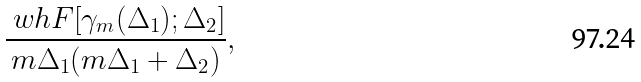Convert formula to latex. <formula><loc_0><loc_0><loc_500><loc_500>\frac { \ w h F [ \gamma _ { m } ( \Delta _ { 1 } ) ; \Delta _ { 2 } ] } { m \Delta _ { 1 } ( m \Delta _ { 1 } + \Delta _ { 2 } ) } ,</formula> 